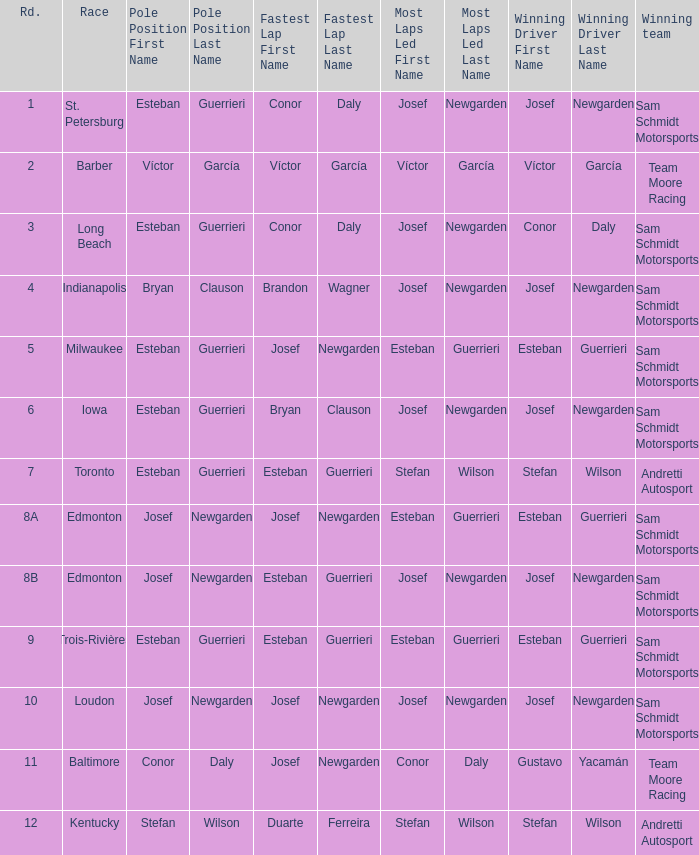Could you help me parse every detail presented in this table? {'header': ['Rd.', 'Race', 'Pole Position First Name', 'Pole Position Last Name', 'Fastest Lap First Name', 'Fastest Lap Last Name', 'Most Laps Led First Name', 'Most Laps Led Last Name', 'Winning Driver First Name', 'Winning Driver Last Name', 'Winning team'], 'rows': [['1', 'St. Petersburg', 'Esteban', 'Guerrieri', 'Conor', 'Daly', 'Josef', 'Newgarden', 'Josef', 'Newgarden', 'Sam Schmidt Motorsports'], ['2', 'Barber', 'Víctor', 'García', 'Víctor', 'García', 'Víctor', 'García', 'Víctor', 'García', 'Team Moore Racing'], ['3', 'Long Beach', 'Esteban', 'Guerrieri', 'Conor', 'Daly', 'Josef', 'Newgarden', 'Conor', 'Daly', 'Sam Schmidt Motorsports'], ['4', 'Indianapolis', 'Bryan', 'Clauson', 'Brandon', 'Wagner', 'Josef', 'Newgarden', 'Josef', 'Newgarden', 'Sam Schmidt Motorsports'], ['5', 'Milwaukee', 'Esteban', 'Guerrieri', 'Josef', 'Newgarden', 'Esteban', 'Guerrieri', 'Esteban', 'Guerrieri', 'Sam Schmidt Motorsports'], ['6', 'Iowa', 'Esteban', 'Guerrieri', 'Bryan', 'Clauson', 'Josef', 'Newgarden', 'Josef', 'Newgarden', 'Sam Schmidt Motorsports'], ['7', 'Toronto', 'Esteban', 'Guerrieri', 'Esteban', 'Guerrieri', 'Stefan', 'Wilson', 'Stefan', 'Wilson', 'Andretti Autosport'], ['8A', 'Edmonton', 'Josef', 'Newgarden', 'Josef', 'Newgarden', 'Esteban', 'Guerrieri', 'Esteban', 'Guerrieri', 'Sam Schmidt Motorsports'], ['8B', 'Edmonton', 'Josef', 'Newgarden', 'Esteban', 'Guerrieri', 'Josef', 'Newgarden', 'Josef', 'Newgarden', 'Sam Schmidt Motorsports'], ['9', 'Trois-Rivières', 'Esteban', 'Guerrieri', 'Esteban', 'Guerrieri', 'Esteban', 'Guerrieri', 'Esteban', 'Guerrieri', 'Sam Schmidt Motorsports'], ['10', 'Loudon', 'Josef', 'Newgarden', 'Josef', 'Newgarden', 'Josef', 'Newgarden', 'Josef', 'Newgarden', 'Sam Schmidt Motorsports'], ['11', 'Baltimore', 'Conor', 'Daly', 'Josef', 'Newgarden', 'Conor', 'Daly', 'Gustavo', 'Yacamán', 'Team Moore Racing'], ['12', 'Kentucky', 'Stefan', 'Wilson', 'Duarte', 'Ferreira', 'Stefan', 'Wilson', 'Stefan', 'Wilson', 'Andretti Autosport']]} Who led the most laps when brandon wagner had the fastest lap? Josef Newgarden. 